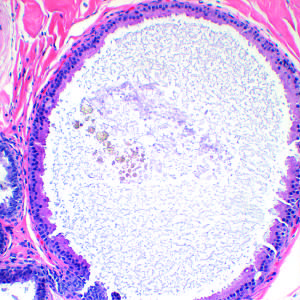s an apocrine cyst a common feature of nonproliferative breast disease?
Answer the question using a single word or phrase. Yes 